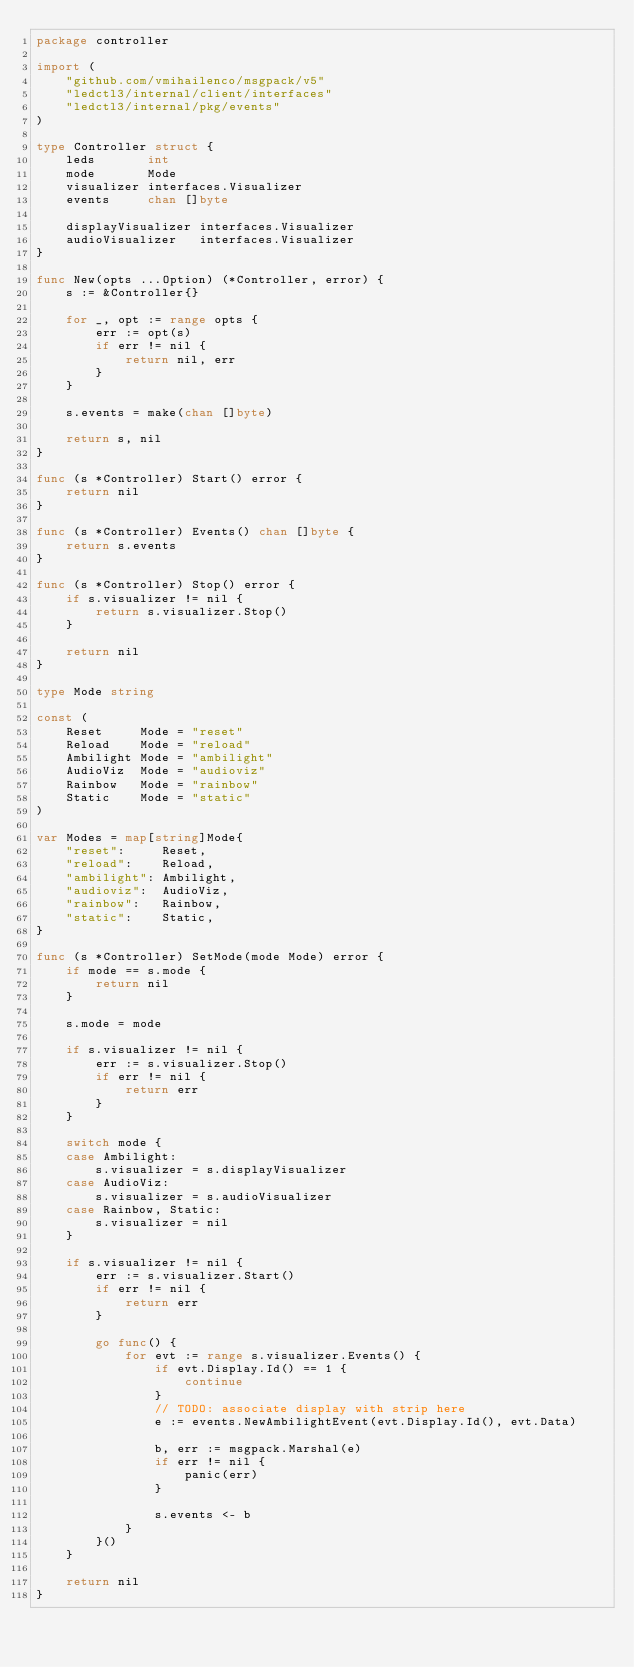Convert code to text. <code><loc_0><loc_0><loc_500><loc_500><_Go_>package controller

import (
	"github.com/vmihailenco/msgpack/v5"
	"ledctl3/internal/client/interfaces"
	"ledctl3/internal/pkg/events"
)

type Controller struct {
	leds       int
	mode       Mode
	visualizer interfaces.Visualizer
	events     chan []byte

	displayVisualizer interfaces.Visualizer
	audioVisualizer   interfaces.Visualizer
}

func New(opts ...Option) (*Controller, error) {
	s := &Controller{}

	for _, opt := range opts {
		err := opt(s)
		if err != nil {
			return nil, err
		}
	}

	s.events = make(chan []byte)

	return s, nil
}

func (s *Controller) Start() error {
	return nil
}

func (s *Controller) Events() chan []byte {
	return s.events
}

func (s *Controller) Stop() error {
	if s.visualizer != nil {
		return s.visualizer.Stop()
	}

	return nil
}

type Mode string

const (
	Reset     Mode = "reset"
	Reload    Mode = "reload"
	Ambilight Mode = "ambilight"
	AudioViz  Mode = "audioviz"
	Rainbow   Mode = "rainbow"
	Static    Mode = "static"
)

var Modes = map[string]Mode{
	"reset":     Reset,
	"reload":    Reload,
	"ambilight": Ambilight,
	"audioviz":  AudioViz,
	"rainbow":   Rainbow,
	"static":    Static,
}

func (s *Controller) SetMode(mode Mode) error {
	if mode == s.mode {
		return nil
	}

	s.mode = mode

	if s.visualizer != nil {
		err := s.visualizer.Stop()
		if err != nil {
			return err
		}
	}

	switch mode {
	case Ambilight:
		s.visualizer = s.displayVisualizer
	case AudioViz:
		s.visualizer = s.audioVisualizer
	case Rainbow, Static:
		s.visualizer = nil
	}

	if s.visualizer != nil {
		err := s.visualizer.Start()
		if err != nil {
			return err
		}

		go func() {
			for evt := range s.visualizer.Events() {
				if evt.Display.Id() == 1 {
					continue
				}
				// TODO: associate display with strip here
				e := events.NewAmbilightEvent(evt.Display.Id(), evt.Data)

				b, err := msgpack.Marshal(e)
				if err != nil {
					panic(err)
				}

				s.events <- b
			}
		}()
	}

	return nil
}
</code> 